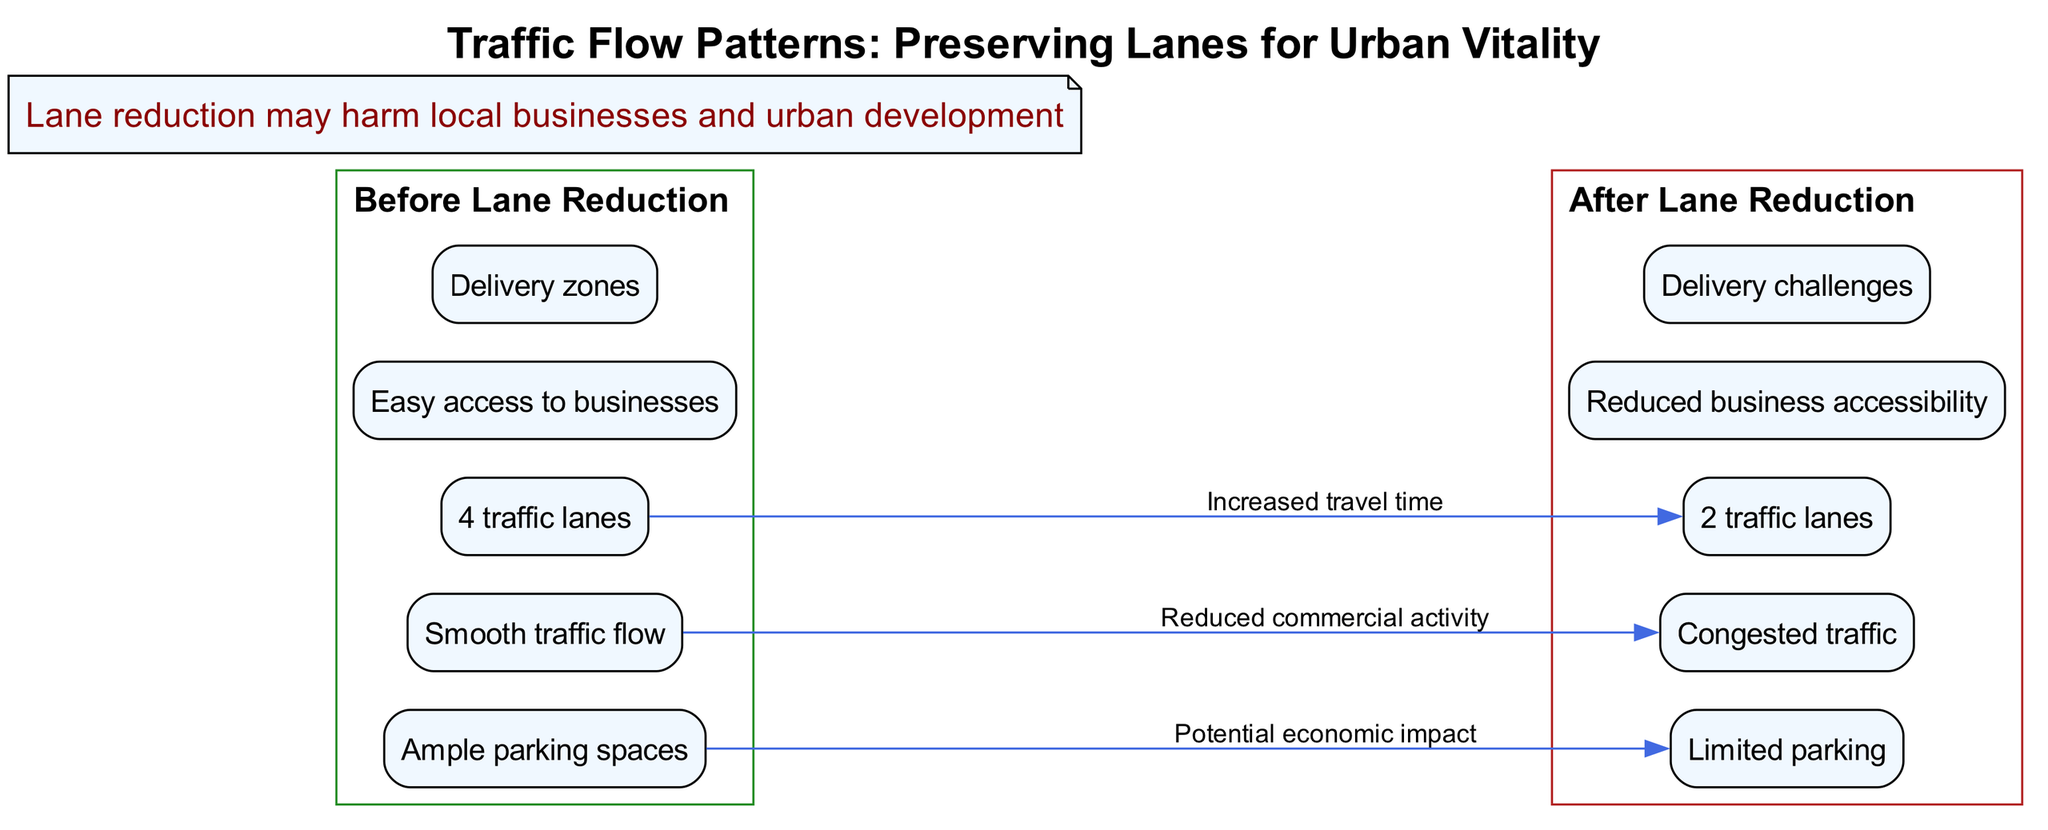What are the number of traffic lanes before lane reduction? The diagram specifies that there are 4 traffic lanes before the lane reduction, as stated in the "Before Lane Reduction" section.
Answer: 4 traffic lanes What is the traffic condition after lane reduction? The "After Lane Reduction" section indicates that the traffic condition is "Congested traffic," highlighting the negative impact on traffic flow.
Answer: Congested traffic What change occurs to parking spaces after lane reduction? The diagram shows a direct change from "Ample parking spaces" before the reduction to "Limited parking" after the reduction, illustrating the impact on parking availability.
Answer: Limited parking How many effects are indicated by arrows between the sections? There are 3 labeled arrows present in the diagram, indicating various effects such as increased travel time and reduced commercial activity in relation to lane reduction.
Answer: 3 What is the main impact of lane reduction highlighted in the callout? The callout states that "Lane reduction may harm local businesses and urban development," summarizing the negative implications of reducing lanes for traffic.
Answer: Harm local businesses and urban development Why is the flow of traffic reduced after lane reduction? The diagram illustrates that the reduction from 4 to 2 lanes leads to "Increased travel time" and "Reduced commercial activity," suggesting causality where fewer lanes result in slower traffic and less business engagement.
Answer: Fewer lanes lead to slower traffic and less business engagement What is the designation of the "Before Lane Reduction" section? The section is labeled "Before Lane Reduction," making it clear that it refers to the traffic situation prior to any changes made to the lanes.
Answer: Before Lane Reduction What challenge is faced by deliveries after lane reduction? The diagram specifies "Delivery challenges" in the "After Lane Reduction" section, indicating that there are difficulties with making deliveries due to the reduced number of lanes.
Answer: Delivery challenges What is the color designation for the "After Lane Reduction" section? The diagram indicates that the "After Lane Reduction" section is color-coded with a red theme, denoting the adverse effects attributed to the lane reduction.
Answer: Red 